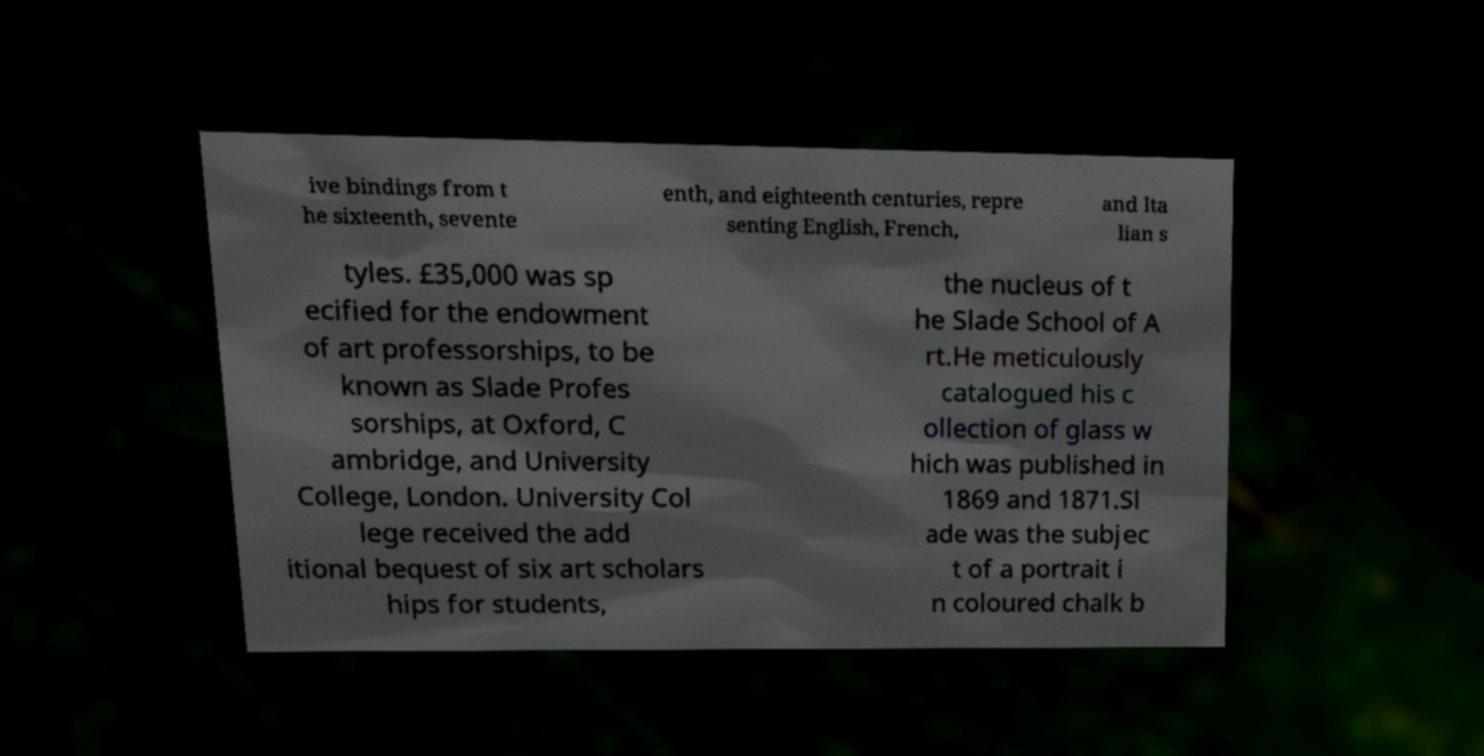Could you extract and type out the text from this image? ive bindings from t he sixteenth, sevente enth, and eighteenth centuries, repre senting English, French, and Ita lian s tyles. £35,000 was sp ecified for the endowment of art professorships, to be known as Slade Profes sorships, at Oxford, C ambridge, and University College, London. University Col lege received the add itional bequest of six art scholars hips for students, the nucleus of t he Slade School of A rt.He meticulously catalogued his c ollection of glass w hich was published in 1869 and 1871.Sl ade was the subjec t of a portrait i n coloured chalk b 